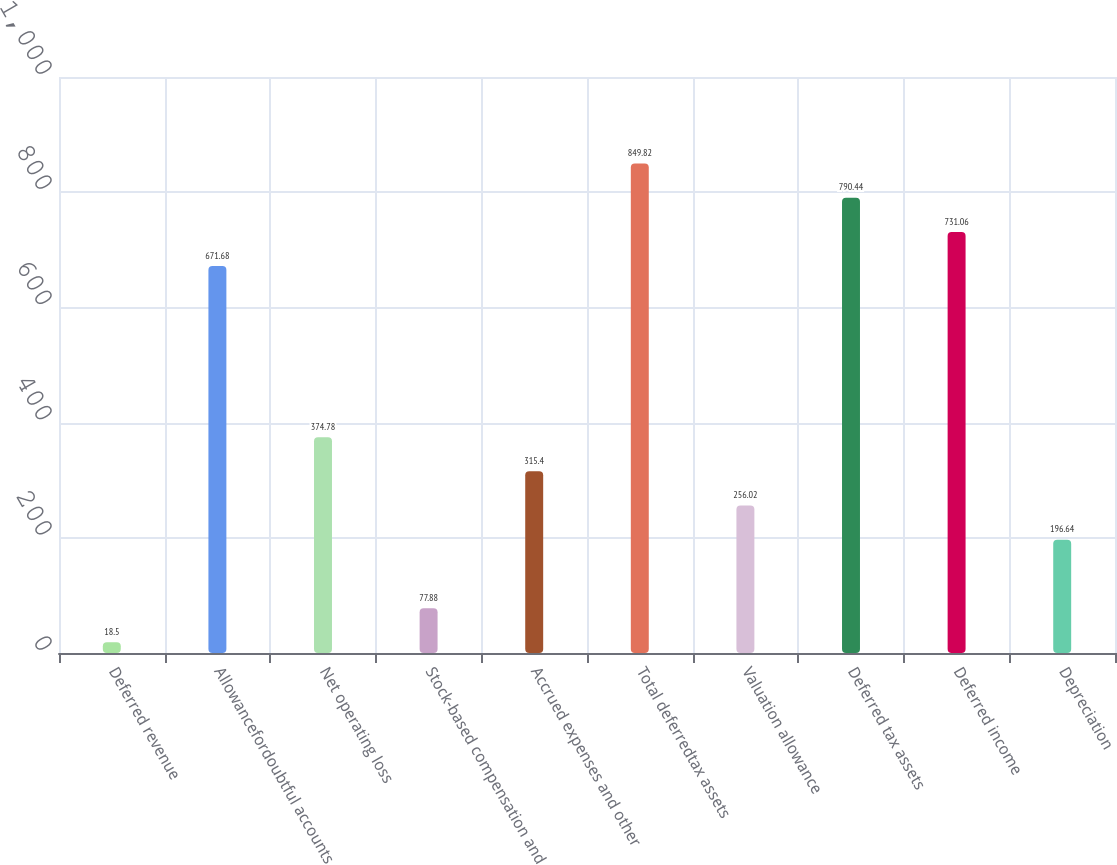Convert chart to OTSL. <chart><loc_0><loc_0><loc_500><loc_500><bar_chart><fcel>Deferred revenue<fcel>Allowancefordoubtful accounts<fcel>Net operating loss<fcel>Stock-based compensation and<fcel>Accrued expenses and other<fcel>Total deferredtax assets<fcel>Valuation allowance<fcel>Deferred tax assets<fcel>Deferred income<fcel>Depreciation<nl><fcel>18.5<fcel>671.68<fcel>374.78<fcel>77.88<fcel>315.4<fcel>849.82<fcel>256.02<fcel>790.44<fcel>731.06<fcel>196.64<nl></chart> 